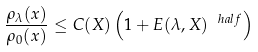<formula> <loc_0><loc_0><loc_500><loc_500>\frac { \rho _ { \lambda } ( x ) } { \rho _ { 0 } ( x ) } \leq C ( X ) \left ( 1 + E ( \lambda , X ) ^ { \ h a l f } \right )</formula> 